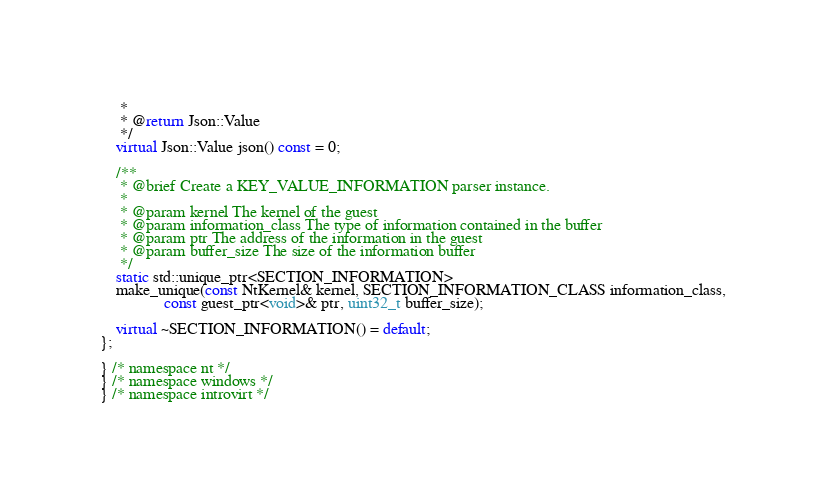Convert code to text. <code><loc_0><loc_0><loc_500><loc_500><_C++_>     *
     * @return Json::Value
     */
    virtual Json::Value json() const = 0;

    /**
     * @brief Create a KEY_VALUE_INFORMATION parser instance.
     *
     * @param kernel The kernel of the guest
     * @param information_class The type of information contained in the buffer
     * @param ptr The address of the information in the guest
     * @param buffer_size The size of the information buffer
     */
    static std::unique_ptr<SECTION_INFORMATION>
    make_unique(const NtKernel& kernel, SECTION_INFORMATION_CLASS information_class,
                const guest_ptr<void>& ptr, uint32_t buffer_size);

    virtual ~SECTION_INFORMATION() = default;
};

} /* namespace nt */
} /* namespace windows */
} /* namespace introvirt */
</code> 